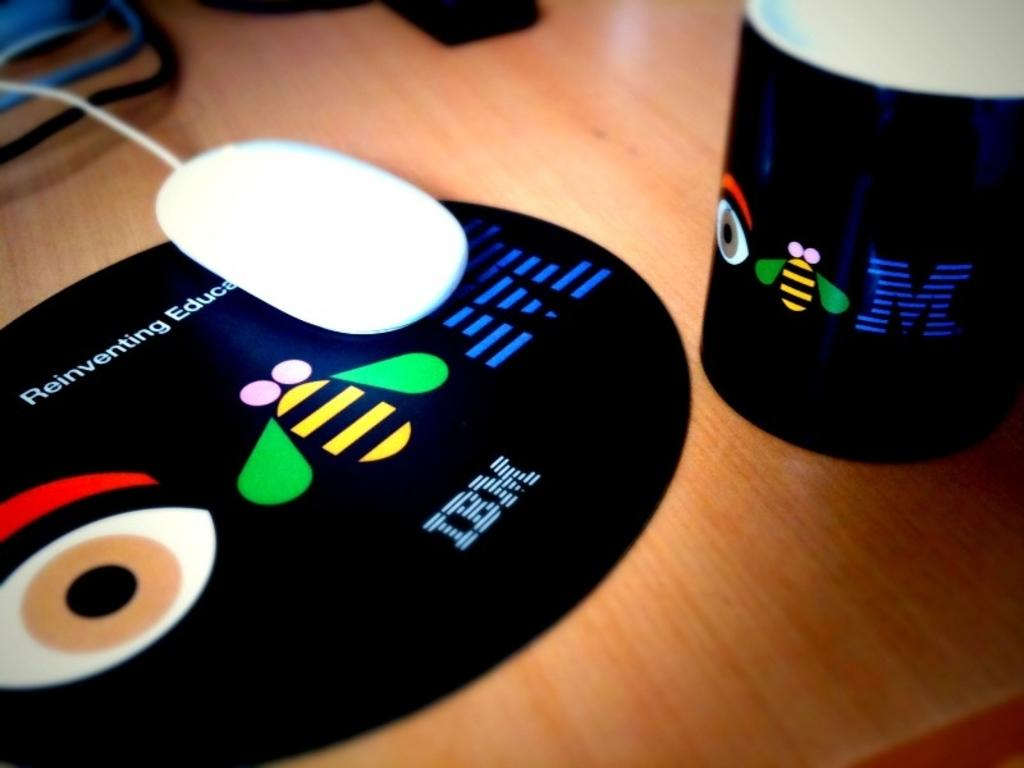<image>
Give a short and clear explanation of the subsequent image. A black mug and mouse mat advertising IBM. 